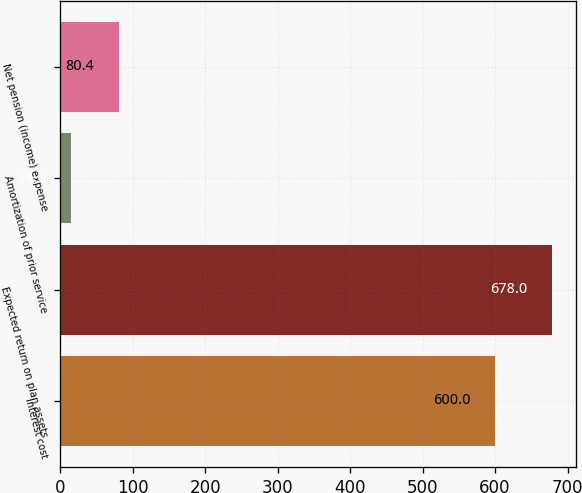<chart> <loc_0><loc_0><loc_500><loc_500><bar_chart><fcel>Interest cost<fcel>Expected return on plan assets<fcel>Amortization of prior service<fcel>Net pension (income) expense<nl><fcel>600<fcel>678<fcel>14<fcel>80.4<nl></chart> 